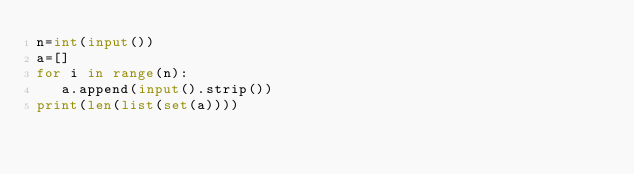<code> <loc_0><loc_0><loc_500><loc_500><_Python_>n=int(input())
a=[]
for i in range(n):
   a.append(input().strip())
print(len(list(set(a))))</code> 